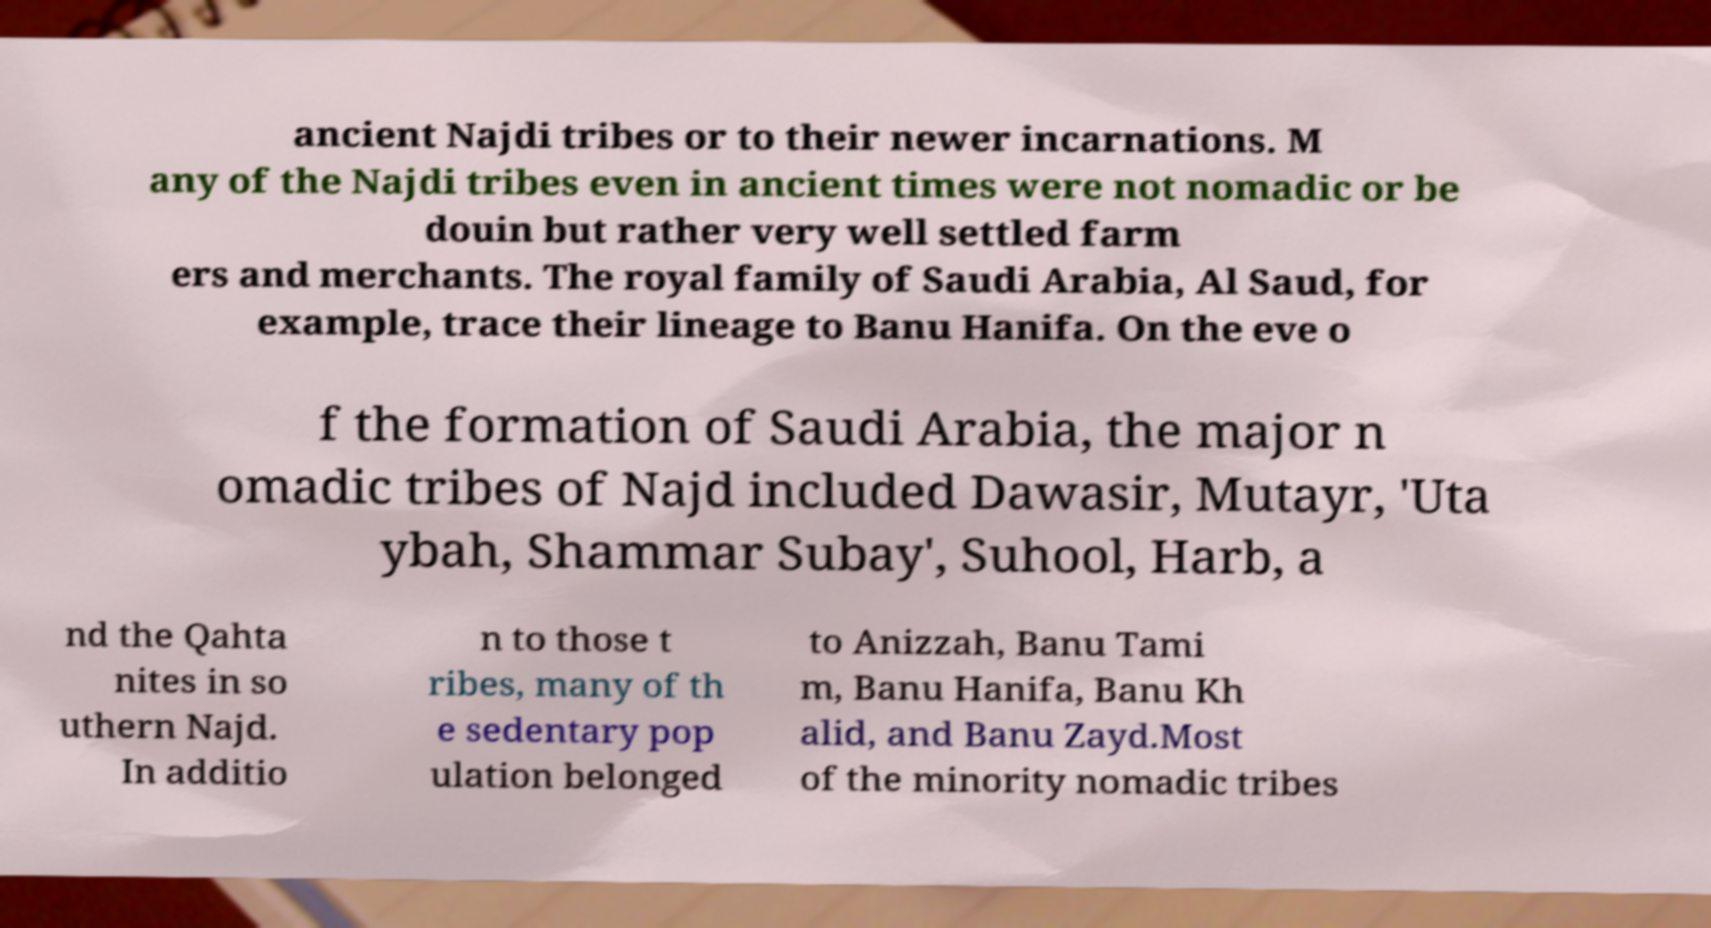There's text embedded in this image that I need extracted. Can you transcribe it verbatim? ancient Najdi tribes or to their newer incarnations. M any of the Najdi tribes even in ancient times were not nomadic or be douin but rather very well settled farm ers and merchants. The royal family of Saudi Arabia, Al Saud, for example, trace their lineage to Banu Hanifa. On the eve o f the formation of Saudi Arabia, the major n omadic tribes of Najd included Dawasir, Mutayr, 'Uta ybah, Shammar Subay', Suhool, Harb, a nd the Qahta nites in so uthern Najd. In additio n to those t ribes, many of th e sedentary pop ulation belonged to Anizzah, Banu Tami m, Banu Hanifa, Banu Kh alid, and Banu Zayd.Most of the minority nomadic tribes 